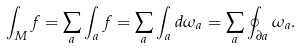Convert formula to latex. <formula><loc_0><loc_0><loc_500><loc_500>\int _ { M } f = \sum _ { a } \int _ { a } f = \sum _ { a } \int _ { a } d \omega _ { a } = \sum _ { a } \oint _ { \partial a } \omega _ { a } .</formula> 